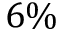<formula> <loc_0><loc_0><loc_500><loc_500>6 \%</formula> 